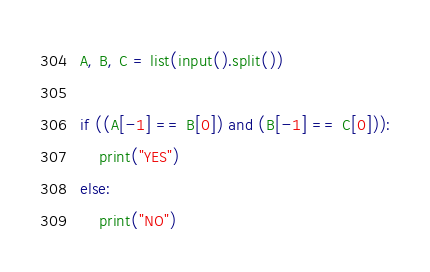<code> <loc_0><loc_0><loc_500><loc_500><_Python_>A, B, C = list(input().split())

if ((A[-1] == B[0]) and (B[-1] == C[0])):
    print("YES")
else:
    print("NO")</code> 